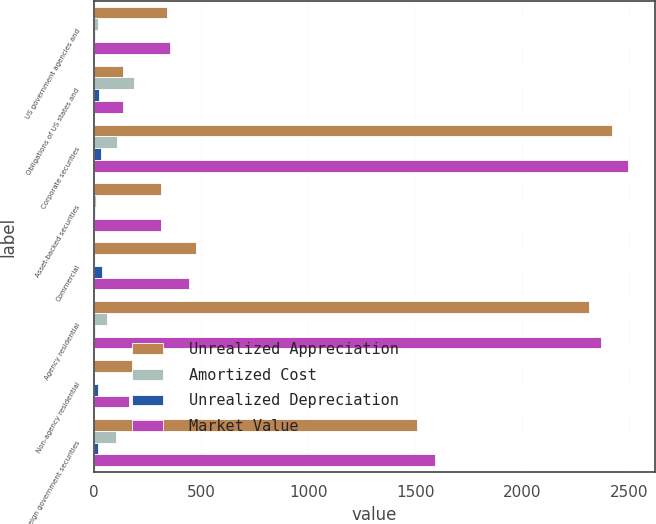<chart> <loc_0><loc_0><loc_500><loc_500><stacked_bar_chart><ecel><fcel>US government agencies and<fcel>Obligations of US states and<fcel>Corporate securities<fcel>Asset-backed securities<fcel>Commercial<fcel>Agency residential<fcel>Non-agency residential<fcel>Foreign government securities<nl><fcel>Unrealized Appreciation<fcel>339.8<fcel>134.2<fcel>2421.9<fcel>310.4<fcel>475.2<fcel>2310.8<fcel>177.5<fcel>1507.4<nl><fcel>Amortized Cost<fcel>17.9<fcel>183.8<fcel>107.8<fcel>7.7<fcel>5.2<fcel>61.5<fcel>0.2<fcel>100.3<nl><fcel>Unrealized Depreciation<fcel>3.5<fcel>24.3<fcel>33<fcel>4.4<fcel>37.8<fcel>3.9<fcel>17.1<fcel>16.9<nl><fcel>Market Value<fcel>354.2<fcel>134.2<fcel>2496.7<fcel>313.7<fcel>442.6<fcel>2368.4<fcel>160.6<fcel>1590.8<nl></chart> 